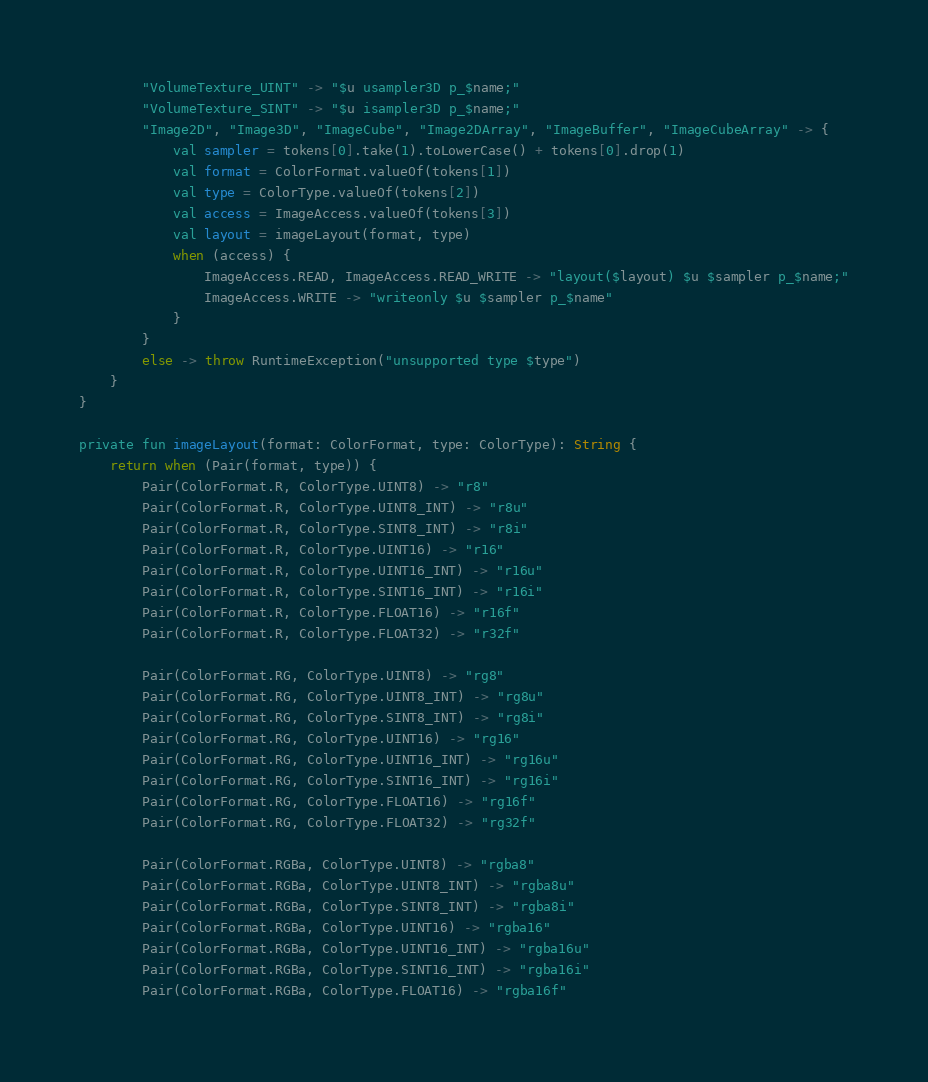Convert code to text. <code><loc_0><loc_0><loc_500><loc_500><_Kotlin_>        "VolumeTexture_UINT" -> "$u usampler3D p_$name;"
        "VolumeTexture_SINT" -> "$u isampler3D p_$name;"
        "Image2D", "Image3D", "ImageCube", "Image2DArray", "ImageBuffer", "ImageCubeArray" -> {
            val sampler = tokens[0].take(1).toLowerCase() + tokens[0].drop(1)
            val format = ColorFormat.valueOf(tokens[1])
            val type = ColorType.valueOf(tokens[2])
            val access = ImageAccess.valueOf(tokens[3])
            val layout = imageLayout(format, type)
            when (access) {
                ImageAccess.READ, ImageAccess.READ_WRITE -> "layout($layout) $u $sampler p_$name;"
                ImageAccess.WRITE -> "writeonly $u $sampler p_$name"
            }
        }
        else -> throw RuntimeException("unsupported type $type")
    }
}

private fun imageLayout(format: ColorFormat, type: ColorType): String {
    return when (Pair(format, type)) {
        Pair(ColorFormat.R, ColorType.UINT8) -> "r8"
        Pair(ColorFormat.R, ColorType.UINT8_INT) -> "r8u"
        Pair(ColorFormat.R, ColorType.SINT8_INT) -> "r8i"
        Pair(ColorFormat.R, ColorType.UINT16) -> "r16"
        Pair(ColorFormat.R, ColorType.UINT16_INT) -> "r16u"
        Pair(ColorFormat.R, ColorType.SINT16_INT) -> "r16i"
        Pair(ColorFormat.R, ColorType.FLOAT16) -> "r16f"
        Pair(ColorFormat.R, ColorType.FLOAT32) -> "r32f"

        Pair(ColorFormat.RG, ColorType.UINT8) -> "rg8"
        Pair(ColorFormat.RG, ColorType.UINT8_INT) -> "rg8u"
        Pair(ColorFormat.RG, ColorType.SINT8_INT) -> "rg8i"
        Pair(ColorFormat.RG, ColorType.UINT16) -> "rg16"
        Pair(ColorFormat.RG, ColorType.UINT16_INT) -> "rg16u"
        Pair(ColorFormat.RG, ColorType.SINT16_INT) -> "rg16i"
        Pair(ColorFormat.RG, ColorType.FLOAT16) -> "rg16f"
        Pair(ColorFormat.RG, ColorType.FLOAT32) -> "rg32f"

        Pair(ColorFormat.RGBa, ColorType.UINT8) -> "rgba8"
        Pair(ColorFormat.RGBa, ColorType.UINT8_INT) -> "rgba8u"
        Pair(ColorFormat.RGBa, ColorType.SINT8_INT) -> "rgba8i"
        Pair(ColorFormat.RGBa, ColorType.UINT16) -> "rgba16"
        Pair(ColorFormat.RGBa, ColorType.UINT16_INT) -> "rgba16u"
        Pair(ColorFormat.RGBa, ColorType.SINT16_INT) -> "rgba16i"
        Pair(ColorFormat.RGBa, ColorType.FLOAT16) -> "rgba16f"</code> 